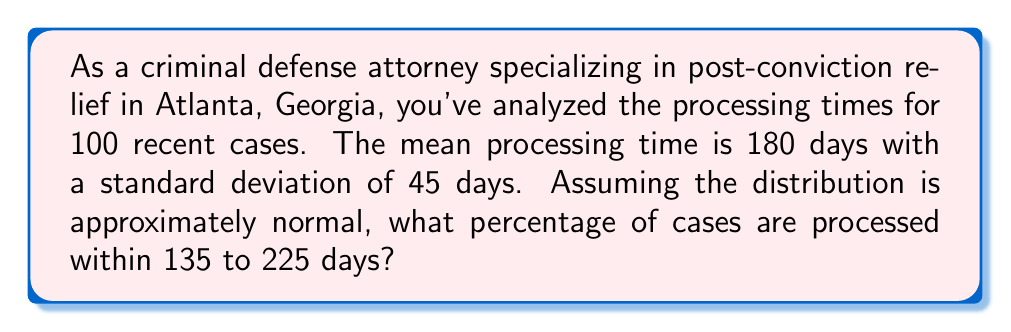What is the answer to this math problem? To solve this problem, we'll use the standard normal distribution (z-score) approach:

1. Calculate the z-scores for the given range:
   For 135 days: $z_1 = \frac{135 - 180}{45} = -1$
   For 225 days: $z_2 = \frac{225 - 180}{45} = 1$

2. The problem asks for the area between z = -1 and z = 1 on a standard normal distribution.

3. Using a standard normal distribution table or calculator:
   P(z ≤ 1) ≈ 0.8413
   P(z ≤ -1) ≈ 0.1587

4. The area between z = -1 and z = 1 is:
   P(-1 ≤ z ≤ 1) = P(z ≤ 1) - P(z ≤ -1)
                 ≈ 0.8413 - 0.1587
                 ≈ 0.6826

5. Convert to percentage:
   0.6826 × 100% ≈ 68.26%

Therefore, approximately 68.26% of cases are processed within 135 to 225 days.
Answer: 68.26% 